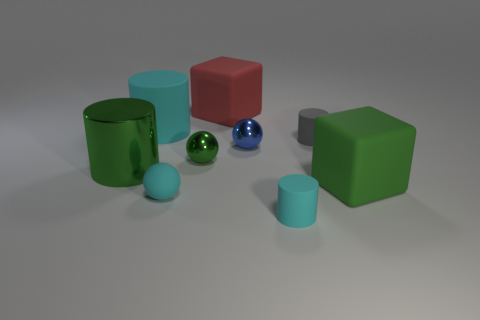Is there another object of the same size as the red object?
Ensure brevity in your answer.  Yes. Are there fewer tiny gray cylinders than big yellow metallic cubes?
Give a very brief answer. No. What number of blocks are either green metal objects or large red rubber objects?
Your response must be concise. 1. How many tiny matte cylinders are the same color as the small matte sphere?
Give a very brief answer. 1. What size is the object that is in front of the tiny gray cylinder and behind the green sphere?
Offer a very short reply. Small. Is the number of green metallic objects that are right of the big cyan thing less than the number of tiny objects?
Offer a terse response. Yes. Do the small cyan ball and the large green cube have the same material?
Ensure brevity in your answer.  Yes. What number of things are big blue metal things or gray rubber things?
Your answer should be compact. 1. What number of small cyan objects are the same material as the tiny blue thing?
Offer a terse response. 0. The gray thing that is the same shape as the big cyan matte object is what size?
Your response must be concise. Small. 